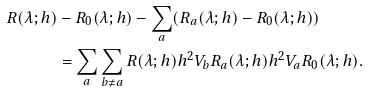Convert formula to latex. <formula><loc_0><loc_0><loc_500><loc_500>R ( \lambda ; h ) & - R _ { 0 } ( \lambda ; h ) - \sum _ { a } ( R _ { a } ( \lambda ; h ) - R _ { 0 } ( \lambda ; h ) ) \\ & = \sum _ { a } \sum _ { b \neq a } R ( \lambda ; h ) h ^ { 2 } V _ { b } R _ { a } ( \lambda ; h ) h ^ { 2 } V _ { a } R _ { 0 } ( \lambda ; h ) .</formula> 